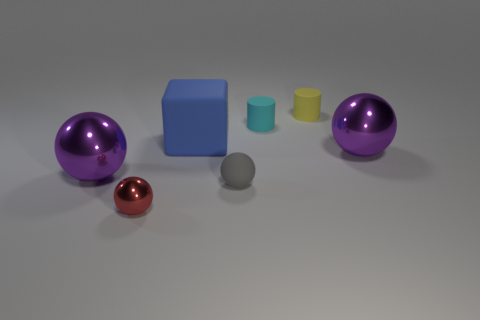Is the shape of the rubber object that is on the left side of the tiny gray thing the same as the large shiny thing that is on the right side of the small yellow rubber cylinder? The shape of the small blue rubber object on the left of the grey sphere is actually a cube, which differs from the large shiny spherical object on the right side of the small yellow cylinder. While both objects have distinct and smooth surfaces, their shapes are fundamentally different: one is a cube and the other is a sphere. 